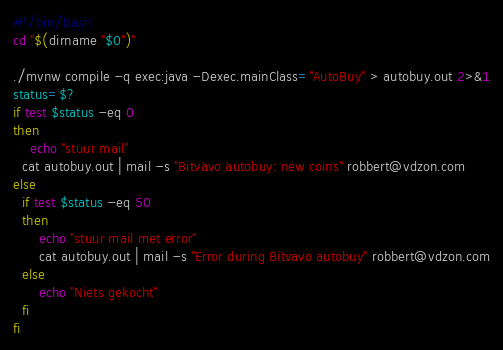Convert code to text. <code><loc_0><loc_0><loc_500><loc_500><_Bash_>#!/bin/bash
cd "$(dirname "$0")"

./mvnw compile -q exec:java -Dexec.mainClass="AutoBuy" > autobuy.out 2>&1
status=$?
if test $status -eq 0
then
	echo "stuur mail"
  cat autobuy.out | mail -s "Bitvavo autobuy: new coins" robbert@vdzon.com
else
  if test $status -eq 50
  then
      echo "stuur mail met error"
      cat autobuy.out | mail -s "Error during Bitvavo autobuy" robbert@vdzon.com
  else
      echo "Niets gekocht"
  fi
fi
</code> 